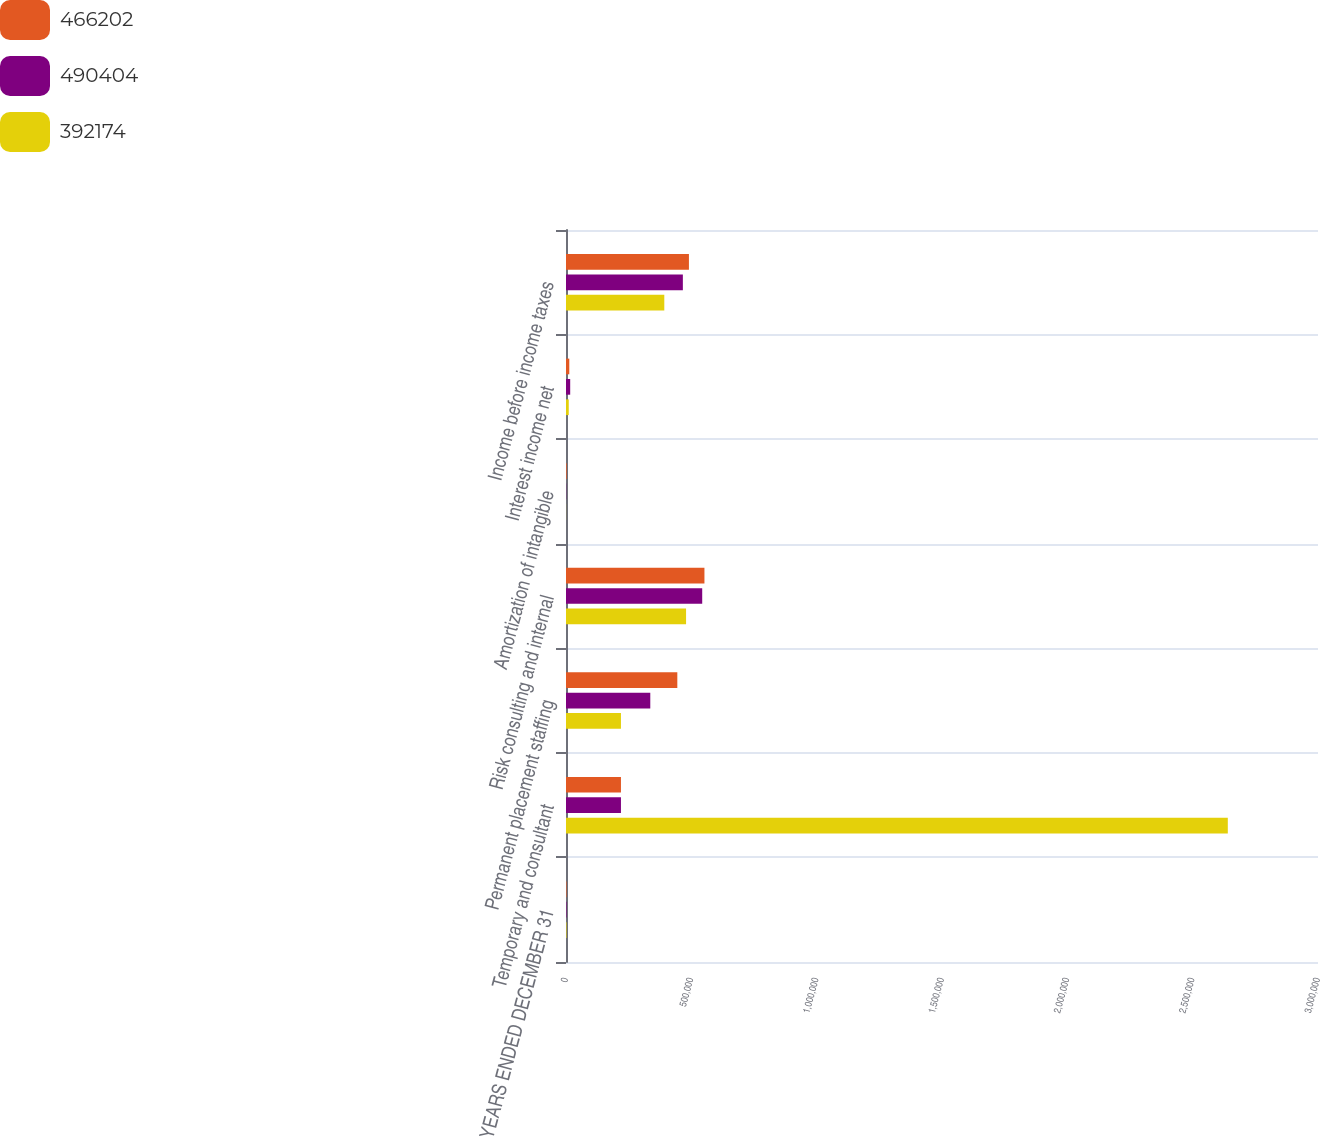Convert chart to OTSL. <chart><loc_0><loc_0><loc_500><loc_500><stacked_bar_chart><ecel><fcel>YEARS ENDED DECEMBER 31<fcel>Temporary and consultant<fcel>Permanent placement staffing<fcel>Risk consulting and internal<fcel>Amortization of intangible<fcel>Interest income net<fcel>Income before income taxes<nl><fcel>466202<fcel>2007<fcel>219234<fcel>444090<fcel>552302<fcel>2594<fcel>13127<fcel>490404<nl><fcel>490404<fcel>2006<fcel>219234<fcel>336250<fcel>543410<fcel>851<fcel>16752<fcel>466202<nl><fcel>392174<fcel>2005<fcel>2.64021e+06<fcel>219234<fcel>478994<fcel>335<fcel>10948<fcel>392174<nl></chart> 